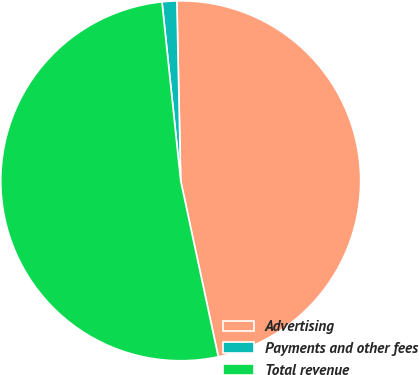Convert chart to OTSL. <chart><loc_0><loc_0><loc_500><loc_500><pie_chart><fcel>Advertising<fcel>Payments and other fees<fcel>Total revenue<nl><fcel>46.99%<fcel>1.32%<fcel>51.69%<nl></chart> 